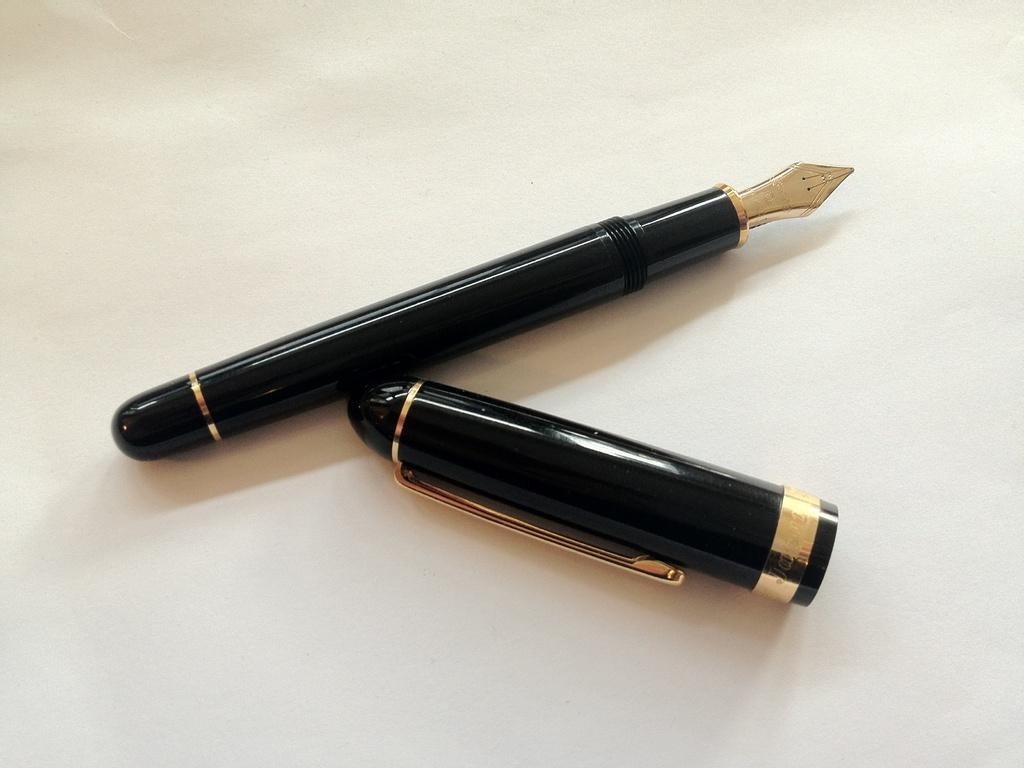What writing instrument is present in the image? There is an ink pen in the image. What is the status of the pen's cap? The cap of the pen is removed. Where is the cap of the pen located in the image? The cap of the pen is placed beside the pen. What type of feast is being prepared in the image? There is no feast present in the image; it only features an ink pen with its cap removed and placed beside it. 